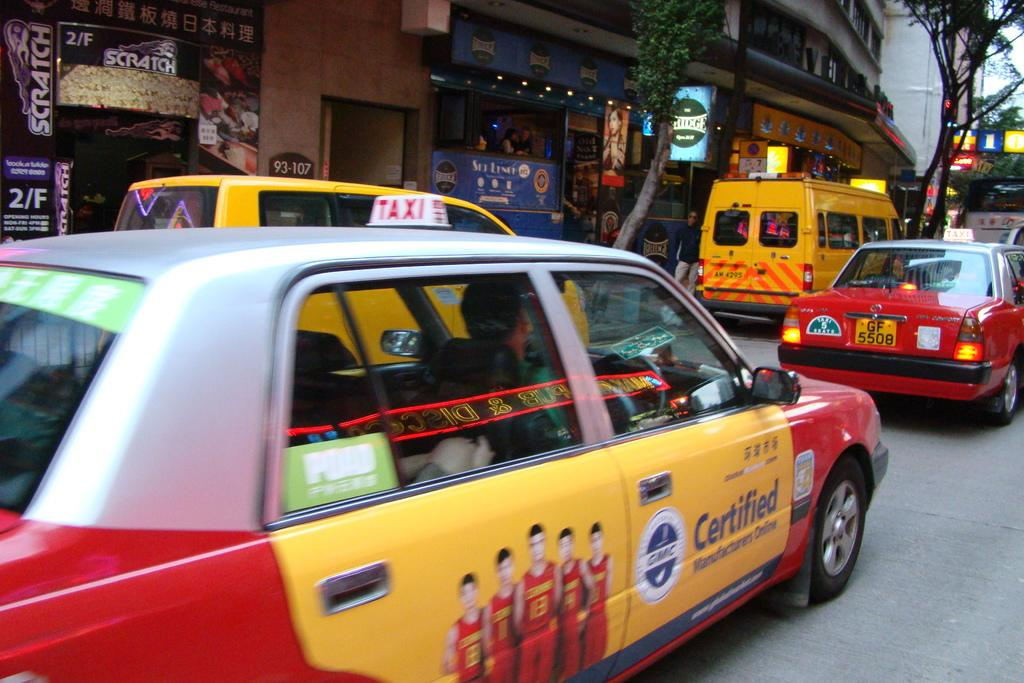<image>
Describe the image concisely. A yellow and red taxi with an add on the side for GMC 